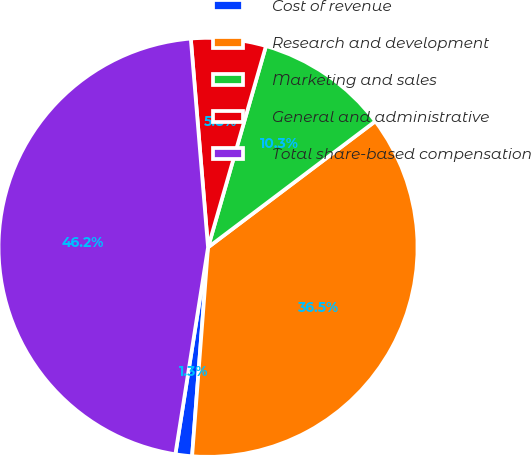<chart> <loc_0><loc_0><loc_500><loc_500><pie_chart><fcel>Cost of revenue<fcel>Research and development<fcel>Marketing and sales<fcel>General and administrative<fcel>Total share-based compensation<nl><fcel>1.28%<fcel>36.49%<fcel>10.26%<fcel>5.77%<fcel>46.19%<nl></chart> 